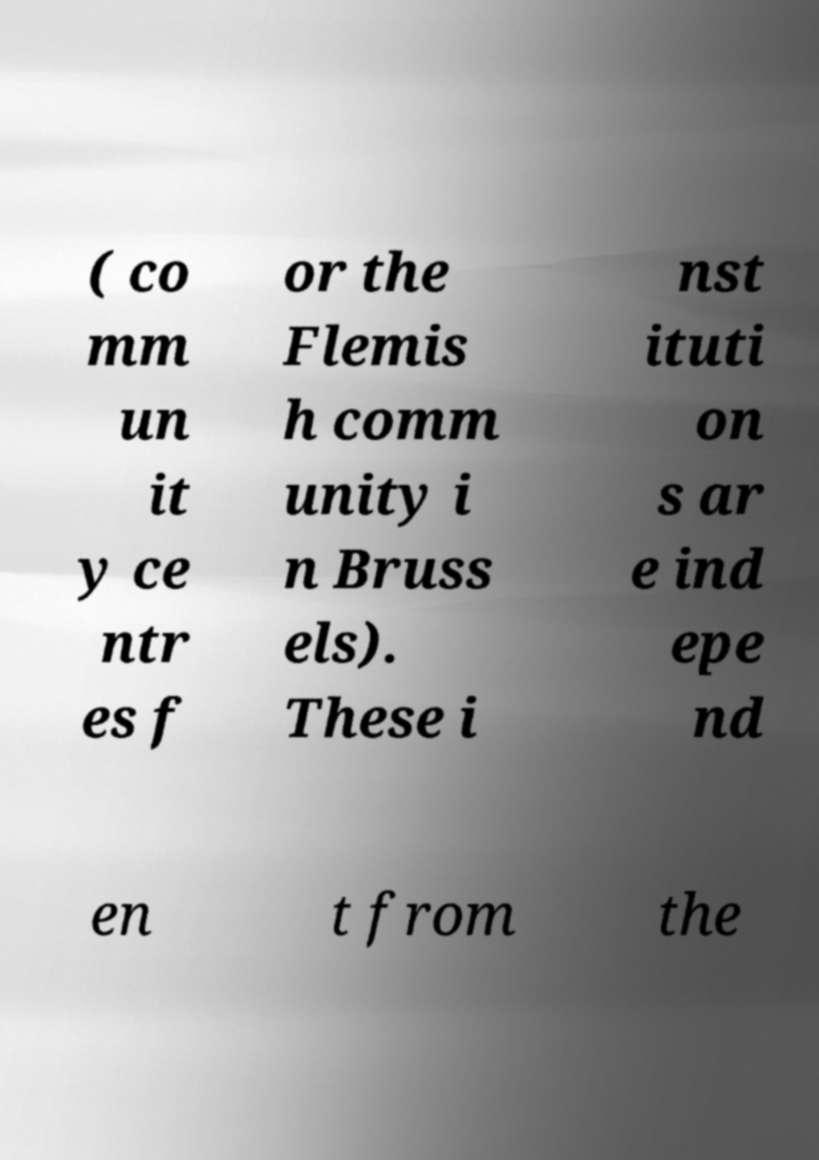For documentation purposes, I need the text within this image transcribed. Could you provide that? ( co mm un it y ce ntr es f or the Flemis h comm unity i n Bruss els). These i nst ituti on s ar e ind epe nd en t from the 